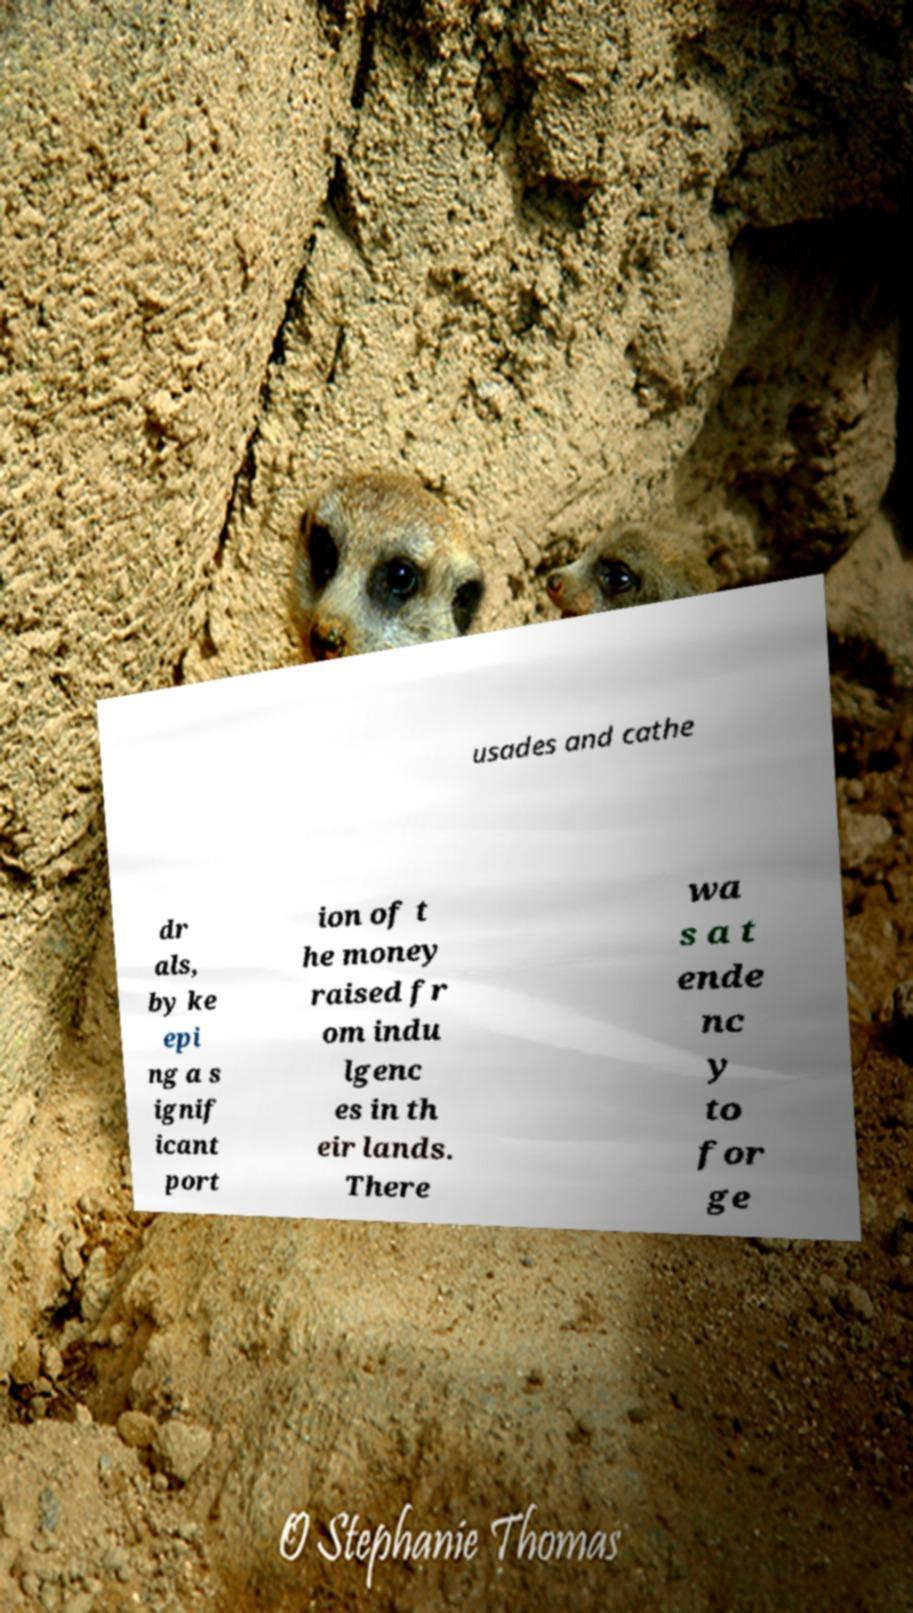Please read and relay the text visible in this image. What does it say? usades and cathe dr als, by ke epi ng a s ignif icant port ion of t he money raised fr om indu lgenc es in th eir lands. There wa s a t ende nc y to for ge 